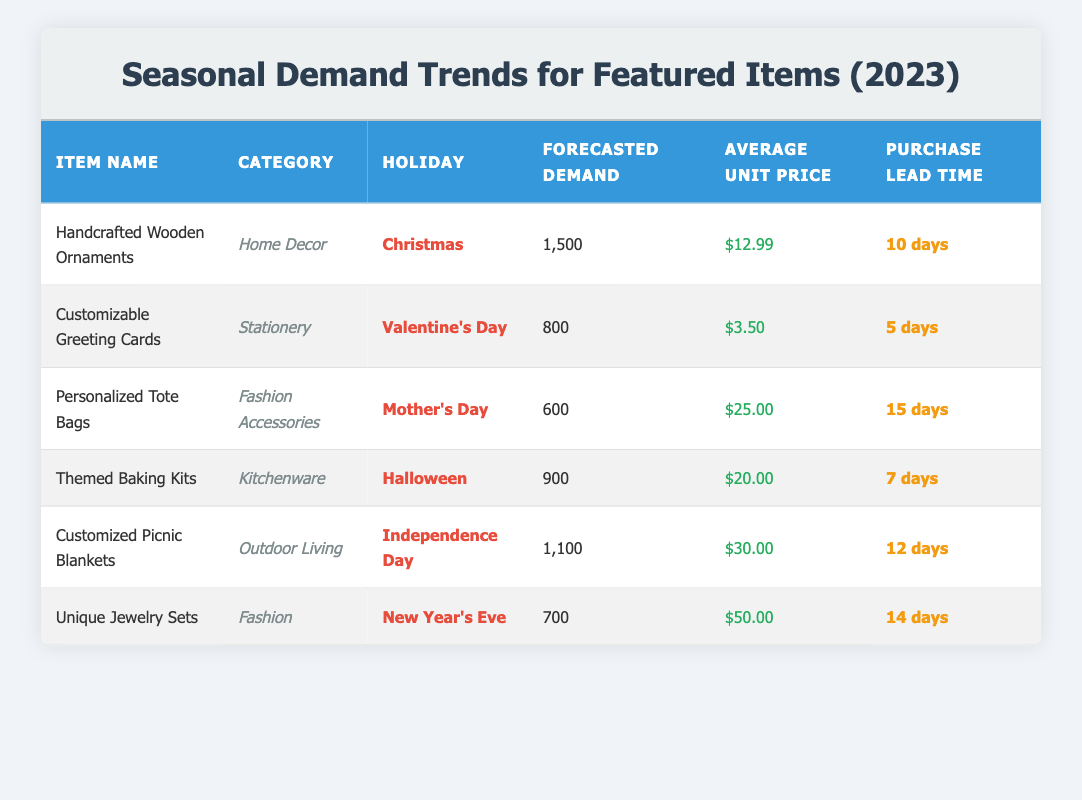What is the forecasted demand for Handcrafted Wooden Ornaments? The table lists the forecasted demand for Handcrafted Wooden Ornaments under the "Forecasted Demand" column, which shows 1,500 units.
Answer: 1,500 Which holiday corresponds to the Personalized Tote Bags? The table shows that Personalized Tote Bags are categorized under the holiday of Mother's Day, as indicated in the "Holiday" column.
Answer: Mother's Day What is the average unit price of Customized Picnic Blankets? The average unit price listed for Customized Picnic Blankets is $30.00, taken directly from the "Average Unit Price" column.
Answer: $30.00 What is the total forecasted demand for items during Valentine's Day and Christmas? The forecasted demand for Valentine's Day (Customizable Greeting Cards) is 800, and for Christmas (Handcrafted Wooden Ornaments) is 1,500. Adding these gives 800 + 1,500 = 2,300.
Answer: 2,300 Is the average unit price of Themed Baking Kits greater than $15? The average unit price for Themed Baking Kits is $20.00, which is indeed greater than $15.
Answer: Yes How many days of purchase lead time is required for Unique Jewelry Sets and Themed Baking Kits combined? The purchase lead time for Unique Jewelry Sets is 14 days and for Themed Baking Kits is 7 days. Adding these gives a total of 14 + 7 = 21 days.
Answer: 21 days Are there more than 1,000 units forecasted for Customized Picnic Blankets? The forecasted demand for Customized Picnic Blankets is 1,100 units, which is more than 1,000.
Answer: Yes What is the difference in forecasted demand between Halloween items and Mother's Day items? The forecasted demand for Halloween (Themed Baking Kits) is 900, and for Mother's Day (Personalized Tote Bags) it is 600. The difference is calculated as 900 - 600 = 300.
Answer: 300 How many of the featured items have an average unit price less than $15? The only item under $15 in the average unit price column is Customizable Greeting Cards at $3.50, so there is just 1 item.
Answer: 1 